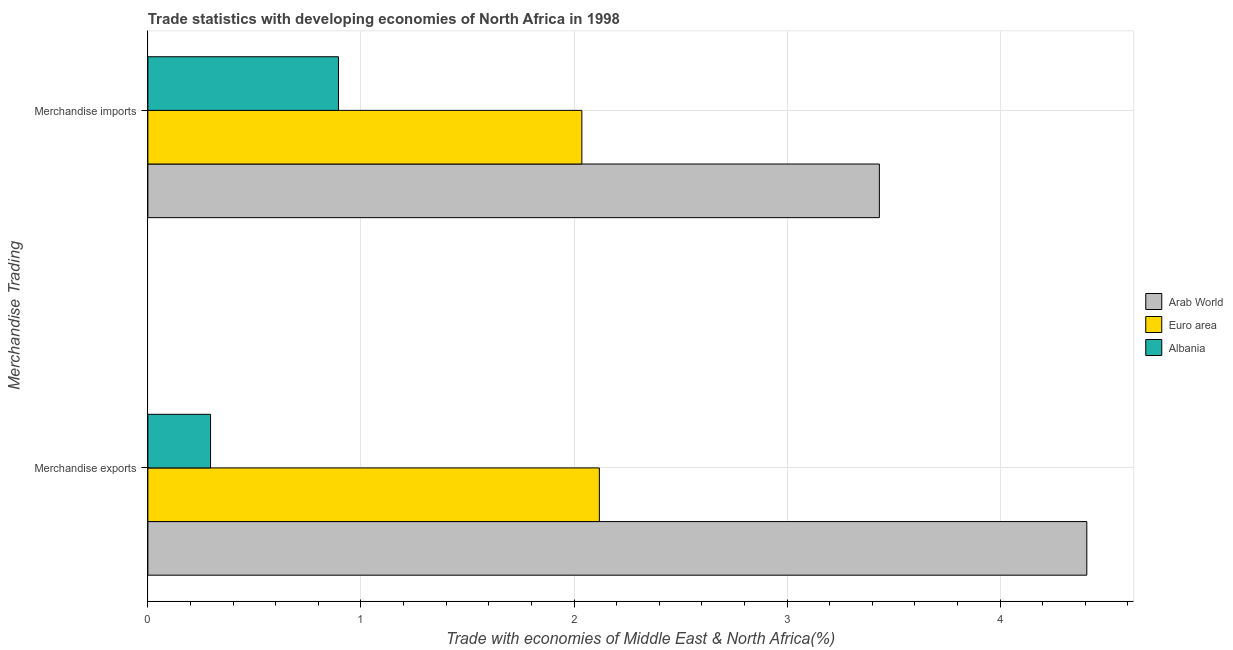Are the number of bars on each tick of the Y-axis equal?
Your response must be concise. Yes. What is the merchandise exports in Euro area?
Provide a succinct answer. 2.12. Across all countries, what is the maximum merchandise exports?
Your response must be concise. 4.41. Across all countries, what is the minimum merchandise imports?
Provide a short and direct response. 0.89. In which country was the merchandise exports maximum?
Ensure brevity in your answer.  Arab World. In which country was the merchandise exports minimum?
Ensure brevity in your answer.  Albania. What is the total merchandise imports in the graph?
Make the answer very short. 6.36. What is the difference between the merchandise exports in Albania and that in Euro area?
Give a very brief answer. -1.82. What is the difference between the merchandise exports in Euro area and the merchandise imports in Albania?
Offer a terse response. 1.22. What is the average merchandise exports per country?
Ensure brevity in your answer.  2.27. What is the difference between the merchandise imports and merchandise exports in Euro area?
Your answer should be very brief. -0.08. In how many countries, is the merchandise exports greater than 2.8 %?
Make the answer very short. 1. What is the ratio of the merchandise imports in Albania to that in Euro area?
Offer a very short reply. 0.44. Is the merchandise imports in Euro area less than that in Arab World?
Provide a succinct answer. Yes. In how many countries, is the merchandise exports greater than the average merchandise exports taken over all countries?
Ensure brevity in your answer.  1. What does the 2nd bar from the top in Merchandise imports represents?
Provide a short and direct response. Euro area. What does the 2nd bar from the bottom in Merchandise imports represents?
Your response must be concise. Euro area. How many bars are there?
Give a very brief answer. 6. How many countries are there in the graph?
Provide a succinct answer. 3. What is the difference between two consecutive major ticks on the X-axis?
Your response must be concise. 1. Are the values on the major ticks of X-axis written in scientific E-notation?
Provide a succinct answer. No. Where does the legend appear in the graph?
Ensure brevity in your answer.  Center right. What is the title of the graph?
Make the answer very short. Trade statistics with developing economies of North Africa in 1998. Does "Cote d'Ivoire" appear as one of the legend labels in the graph?
Your answer should be very brief. No. What is the label or title of the X-axis?
Offer a terse response. Trade with economies of Middle East & North Africa(%). What is the label or title of the Y-axis?
Provide a short and direct response. Merchandise Trading. What is the Trade with economies of Middle East & North Africa(%) in Arab World in Merchandise exports?
Provide a succinct answer. 4.41. What is the Trade with economies of Middle East & North Africa(%) of Euro area in Merchandise exports?
Make the answer very short. 2.12. What is the Trade with economies of Middle East & North Africa(%) of Albania in Merchandise exports?
Your response must be concise. 0.29. What is the Trade with economies of Middle East & North Africa(%) in Arab World in Merchandise imports?
Offer a very short reply. 3.43. What is the Trade with economies of Middle East & North Africa(%) of Euro area in Merchandise imports?
Offer a very short reply. 2.04. What is the Trade with economies of Middle East & North Africa(%) in Albania in Merchandise imports?
Offer a terse response. 0.89. Across all Merchandise Trading, what is the maximum Trade with economies of Middle East & North Africa(%) in Arab World?
Ensure brevity in your answer.  4.41. Across all Merchandise Trading, what is the maximum Trade with economies of Middle East & North Africa(%) of Euro area?
Provide a short and direct response. 2.12. Across all Merchandise Trading, what is the maximum Trade with economies of Middle East & North Africa(%) in Albania?
Provide a succinct answer. 0.89. Across all Merchandise Trading, what is the minimum Trade with economies of Middle East & North Africa(%) in Arab World?
Provide a short and direct response. 3.43. Across all Merchandise Trading, what is the minimum Trade with economies of Middle East & North Africa(%) in Euro area?
Your response must be concise. 2.04. Across all Merchandise Trading, what is the minimum Trade with economies of Middle East & North Africa(%) of Albania?
Provide a short and direct response. 0.29. What is the total Trade with economies of Middle East & North Africa(%) in Arab World in the graph?
Your response must be concise. 7.84. What is the total Trade with economies of Middle East & North Africa(%) of Euro area in the graph?
Offer a terse response. 4.16. What is the total Trade with economies of Middle East & North Africa(%) in Albania in the graph?
Ensure brevity in your answer.  1.19. What is the difference between the Trade with economies of Middle East & North Africa(%) in Arab World in Merchandise exports and that in Merchandise imports?
Your answer should be very brief. 0.97. What is the difference between the Trade with economies of Middle East & North Africa(%) in Euro area in Merchandise exports and that in Merchandise imports?
Offer a very short reply. 0.08. What is the difference between the Trade with economies of Middle East & North Africa(%) of Albania in Merchandise exports and that in Merchandise imports?
Give a very brief answer. -0.6. What is the difference between the Trade with economies of Middle East & North Africa(%) of Arab World in Merchandise exports and the Trade with economies of Middle East & North Africa(%) of Euro area in Merchandise imports?
Your answer should be very brief. 2.37. What is the difference between the Trade with economies of Middle East & North Africa(%) of Arab World in Merchandise exports and the Trade with economies of Middle East & North Africa(%) of Albania in Merchandise imports?
Offer a very short reply. 3.51. What is the difference between the Trade with economies of Middle East & North Africa(%) of Euro area in Merchandise exports and the Trade with economies of Middle East & North Africa(%) of Albania in Merchandise imports?
Ensure brevity in your answer.  1.22. What is the average Trade with economies of Middle East & North Africa(%) in Arab World per Merchandise Trading?
Your answer should be very brief. 3.92. What is the average Trade with economies of Middle East & North Africa(%) in Euro area per Merchandise Trading?
Offer a terse response. 2.08. What is the average Trade with economies of Middle East & North Africa(%) of Albania per Merchandise Trading?
Make the answer very short. 0.59. What is the difference between the Trade with economies of Middle East & North Africa(%) of Arab World and Trade with economies of Middle East & North Africa(%) of Euro area in Merchandise exports?
Your answer should be compact. 2.29. What is the difference between the Trade with economies of Middle East & North Africa(%) of Arab World and Trade with economies of Middle East & North Africa(%) of Albania in Merchandise exports?
Keep it short and to the point. 4.11. What is the difference between the Trade with economies of Middle East & North Africa(%) in Euro area and Trade with economies of Middle East & North Africa(%) in Albania in Merchandise exports?
Make the answer very short. 1.82. What is the difference between the Trade with economies of Middle East & North Africa(%) of Arab World and Trade with economies of Middle East & North Africa(%) of Euro area in Merchandise imports?
Ensure brevity in your answer.  1.4. What is the difference between the Trade with economies of Middle East & North Africa(%) of Arab World and Trade with economies of Middle East & North Africa(%) of Albania in Merchandise imports?
Keep it short and to the point. 2.54. What is the difference between the Trade with economies of Middle East & North Africa(%) in Euro area and Trade with economies of Middle East & North Africa(%) in Albania in Merchandise imports?
Give a very brief answer. 1.14. What is the ratio of the Trade with economies of Middle East & North Africa(%) of Arab World in Merchandise exports to that in Merchandise imports?
Provide a short and direct response. 1.28. What is the ratio of the Trade with economies of Middle East & North Africa(%) of Euro area in Merchandise exports to that in Merchandise imports?
Ensure brevity in your answer.  1.04. What is the ratio of the Trade with economies of Middle East & North Africa(%) in Albania in Merchandise exports to that in Merchandise imports?
Offer a very short reply. 0.33. What is the difference between the highest and the second highest Trade with economies of Middle East & North Africa(%) in Arab World?
Your answer should be compact. 0.97. What is the difference between the highest and the second highest Trade with economies of Middle East & North Africa(%) of Euro area?
Your answer should be compact. 0.08. What is the difference between the highest and the second highest Trade with economies of Middle East & North Africa(%) in Albania?
Provide a short and direct response. 0.6. What is the difference between the highest and the lowest Trade with economies of Middle East & North Africa(%) of Arab World?
Your answer should be compact. 0.97. What is the difference between the highest and the lowest Trade with economies of Middle East & North Africa(%) of Euro area?
Your answer should be compact. 0.08. What is the difference between the highest and the lowest Trade with economies of Middle East & North Africa(%) of Albania?
Provide a short and direct response. 0.6. 